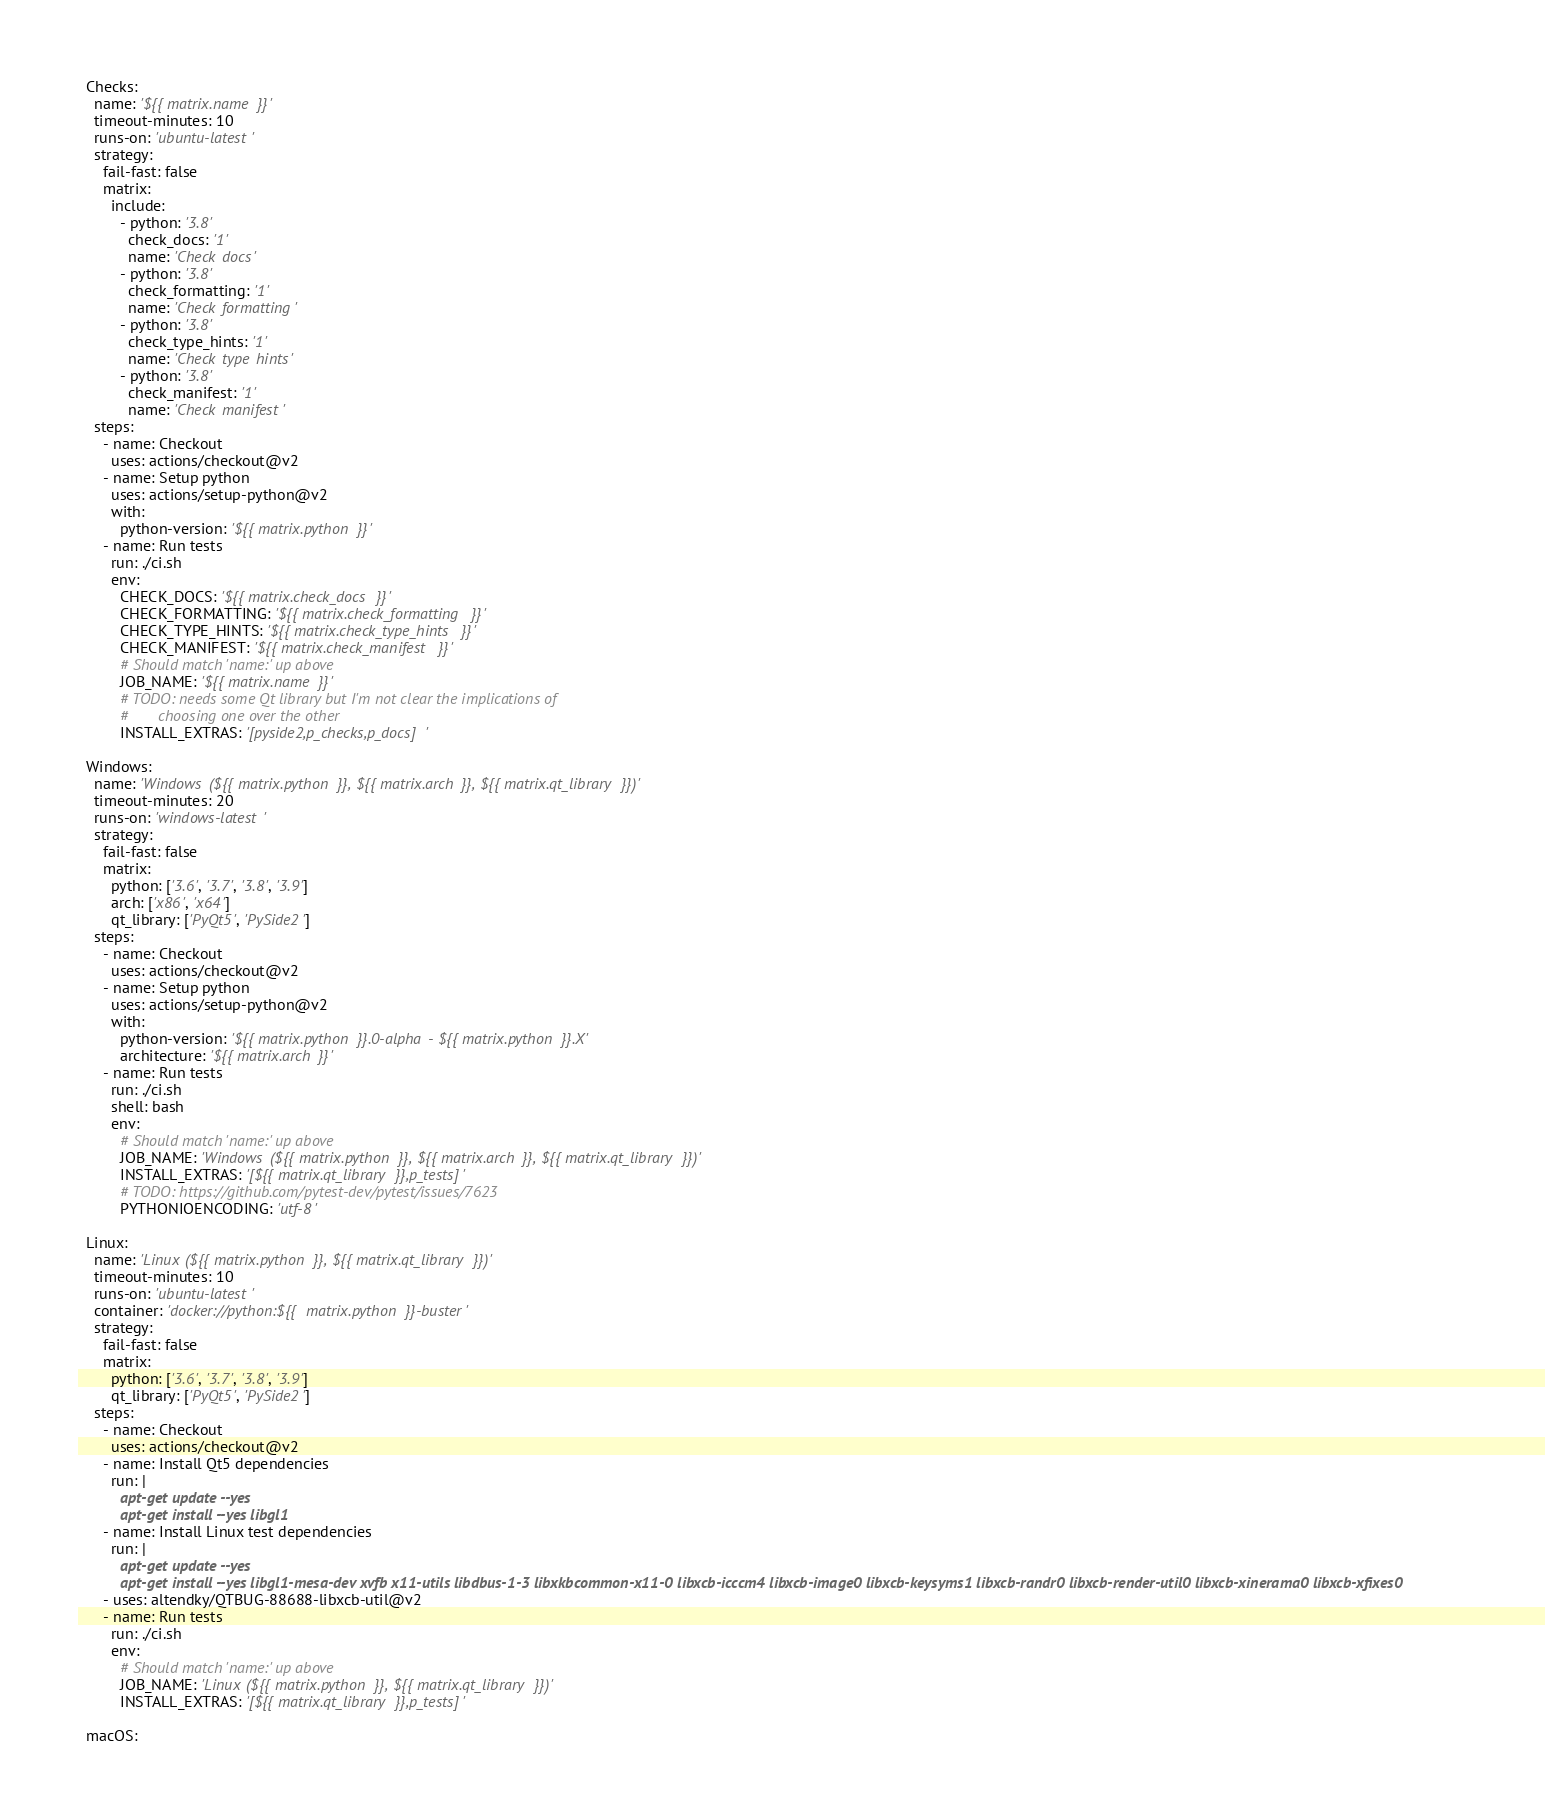<code> <loc_0><loc_0><loc_500><loc_500><_YAML_>  Checks:
    name: '${{ matrix.name }}'
    timeout-minutes: 10
    runs-on: 'ubuntu-latest'
    strategy:
      fail-fast: false
      matrix:
        include:
          - python: '3.8'
            check_docs: '1'
            name: 'Check docs'
          - python: '3.8'
            check_formatting: '1'
            name: 'Check formatting'
          - python: '3.8'
            check_type_hints: '1'
            name: 'Check type hints'
          - python: '3.8'
            check_manifest: '1'
            name: 'Check manifest'
    steps:
      - name: Checkout
        uses: actions/checkout@v2
      - name: Setup python
        uses: actions/setup-python@v2
        with:
          python-version: '${{ matrix.python }}'
      - name: Run tests
        run: ./ci.sh
        env:
          CHECK_DOCS: '${{ matrix.check_docs }}'
          CHECK_FORMATTING: '${{ matrix.check_formatting }}'
          CHECK_TYPE_HINTS: '${{ matrix.check_type_hints }}'
          CHECK_MANIFEST: '${{ matrix.check_manifest }}'
          # Should match 'name:' up above
          JOB_NAME: '${{ matrix.name }}'
          # TODO: needs some Qt library but I'm not clear the implications of
          #       choosing one over the other
          INSTALL_EXTRAS: '[pyside2,p_checks,p_docs]'

  Windows:
    name: 'Windows (${{ matrix.python }}, ${{ matrix.arch }}, ${{ matrix.qt_library }})'
    timeout-minutes: 20
    runs-on: 'windows-latest'
    strategy:
      fail-fast: false
      matrix:
        python: ['3.6', '3.7', '3.8', '3.9']
        arch: ['x86', 'x64']
        qt_library: ['PyQt5', 'PySide2']
    steps:
      - name: Checkout
        uses: actions/checkout@v2
      - name: Setup python
        uses: actions/setup-python@v2
        with:
          python-version: '${{ matrix.python }}.0-alpha - ${{ matrix.python }}.X'
          architecture: '${{ matrix.arch }}'
      - name: Run tests
        run: ./ci.sh
        shell: bash
        env:
          # Should match 'name:' up above
          JOB_NAME: 'Windows (${{ matrix.python }}, ${{ matrix.arch }}, ${{ matrix.qt_library }})'
          INSTALL_EXTRAS: '[${{ matrix.qt_library }},p_tests]'
          # TODO: https://github.com/pytest-dev/pytest/issues/7623
          PYTHONIOENCODING: 'utf-8'

  Linux:
    name: 'Linux (${{ matrix.python }}, ${{ matrix.qt_library }})'
    timeout-minutes: 10
    runs-on: 'ubuntu-latest'
    container: 'docker://python:${{ matrix.python }}-buster'
    strategy:
      fail-fast: false
      matrix:
        python: ['3.6', '3.7', '3.8', '3.9']
        qt_library: ['PyQt5', 'PySide2']
    steps:
      - name: Checkout
        uses: actions/checkout@v2
      - name: Install Qt5 dependencies
        run: |
          apt-get update --yes
          apt-get install --yes libgl1
      - name: Install Linux test dependencies
        run: |
          apt-get update --yes
          apt-get install --yes libgl1-mesa-dev xvfb x11-utils libdbus-1-3 libxkbcommon-x11-0 libxcb-icccm4 libxcb-image0 libxcb-keysyms1 libxcb-randr0 libxcb-render-util0 libxcb-xinerama0 libxcb-xfixes0
      - uses: altendky/QTBUG-88688-libxcb-util@v2
      - name: Run tests
        run: ./ci.sh
        env:
          # Should match 'name:' up above
          JOB_NAME: 'Linux (${{ matrix.python }}, ${{ matrix.qt_library }})'
          INSTALL_EXTRAS: '[${{ matrix.qt_library }},p_tests]'

  macOS:</code> 